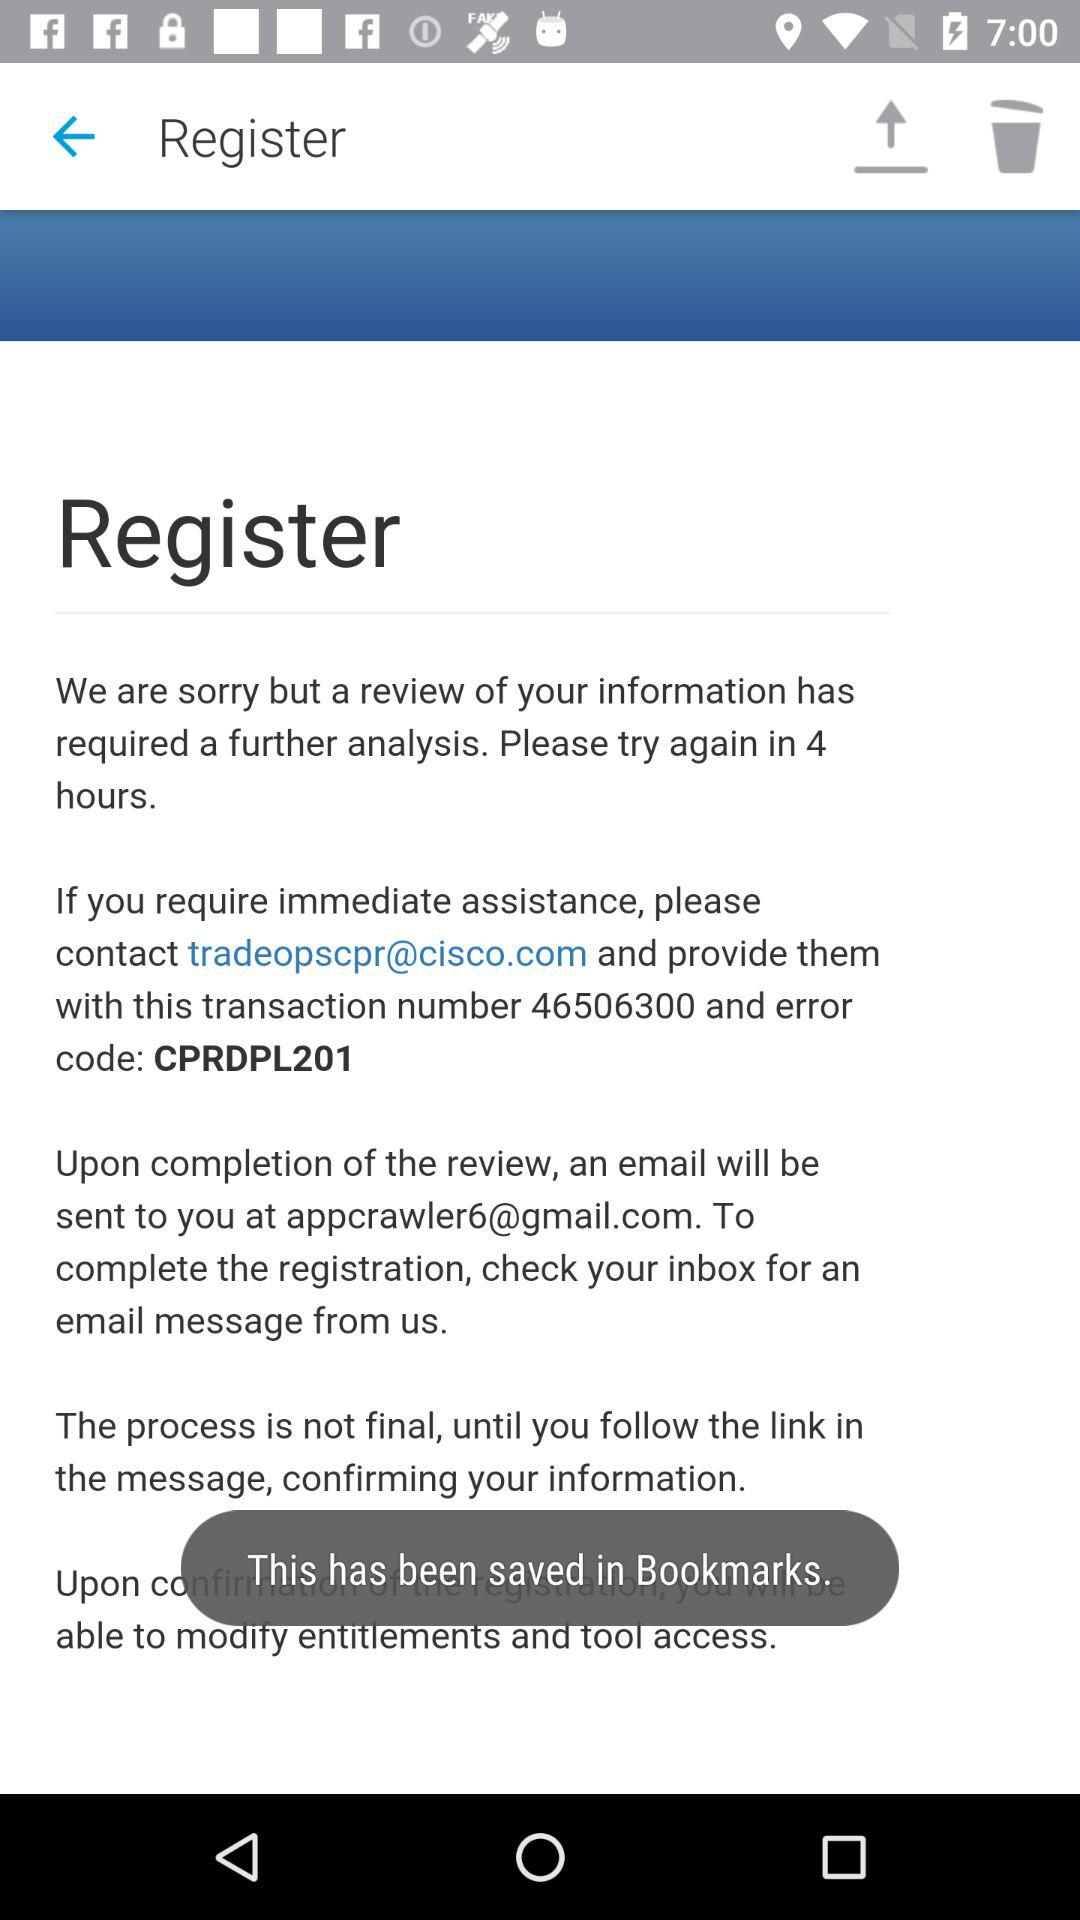What is the error code? The error code is CPRDPL201. 